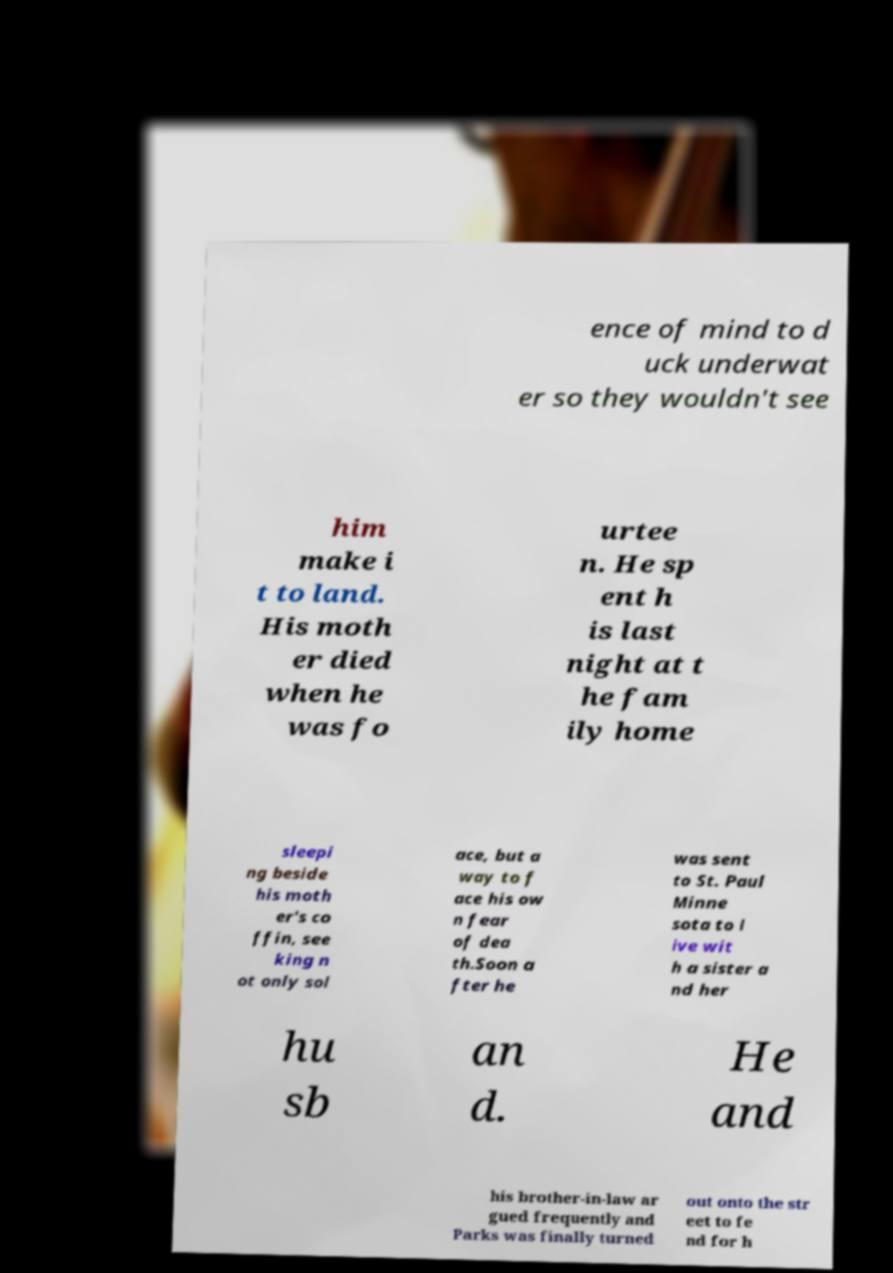Could you extract and type out the text from this image? ence of mind to d uck underwat er so they wouldn't see him make i t to land. His moth er died when he was fo urtee n. He sp ent h is last night at t he fam ily home sleepi ng beside his moth er's co ffin, see king n ot only sol ace, but a way to f ace his ow n fear of dea th.Soon a fter he was sent to St. Paul Minne sota to l ive wit h a sister a nd her hu sb an d. He and his brother-in-law ar gued frequently and Parks was finally turned out onto the str eet to fe nd for h 